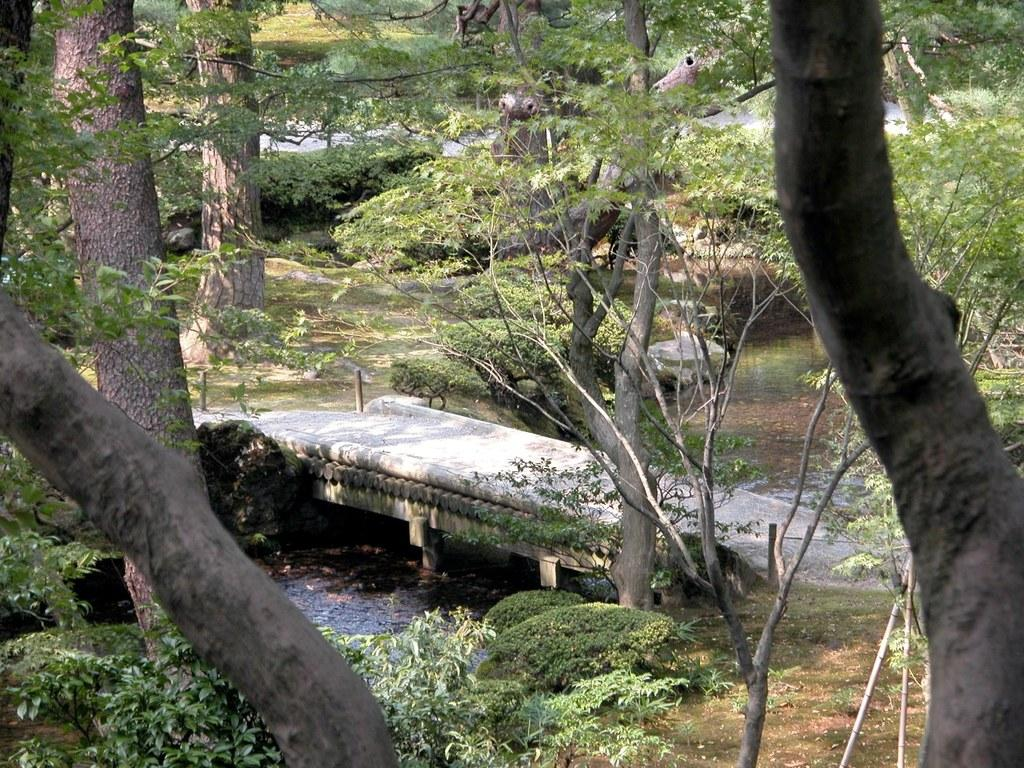What type of natural elements can be seen in the image? There are trees and plants in the image. What man-made structure is present in the image? There is a bridge in the image. What is the body of water in the image? There is water visible in the image. What type of stamp can be seen on the bridge in the image? There is no stamp present on the bridge in the image. How many ducks are swimming in the water in the image? There are no ducks visible in the image. 